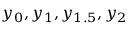<formula> <loc_0><loc_0><loc_500><loc_500>y _ { 0 } , y _ { 1 } , y _ { 1 . 5 } , y _ { 2 }</formula> 